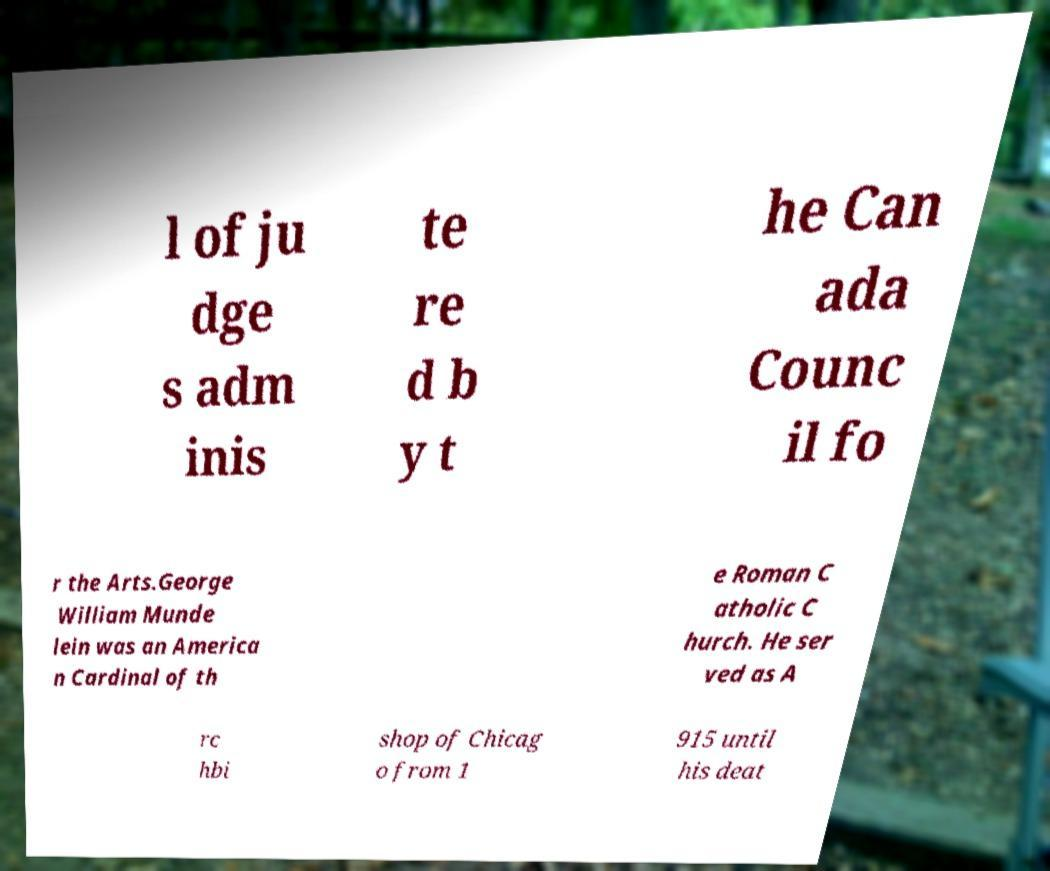Please read and relay the text visible in this image. What does it say? l of ju dge s adm inis te re d b y t he Can ada Counc il fo r the Arts.George William Munde lein was an America n Cardinal of th e Roman C atholic C hurch. He ser ved as A rc hbi shop of Chicag o from 1 915 until his deat 